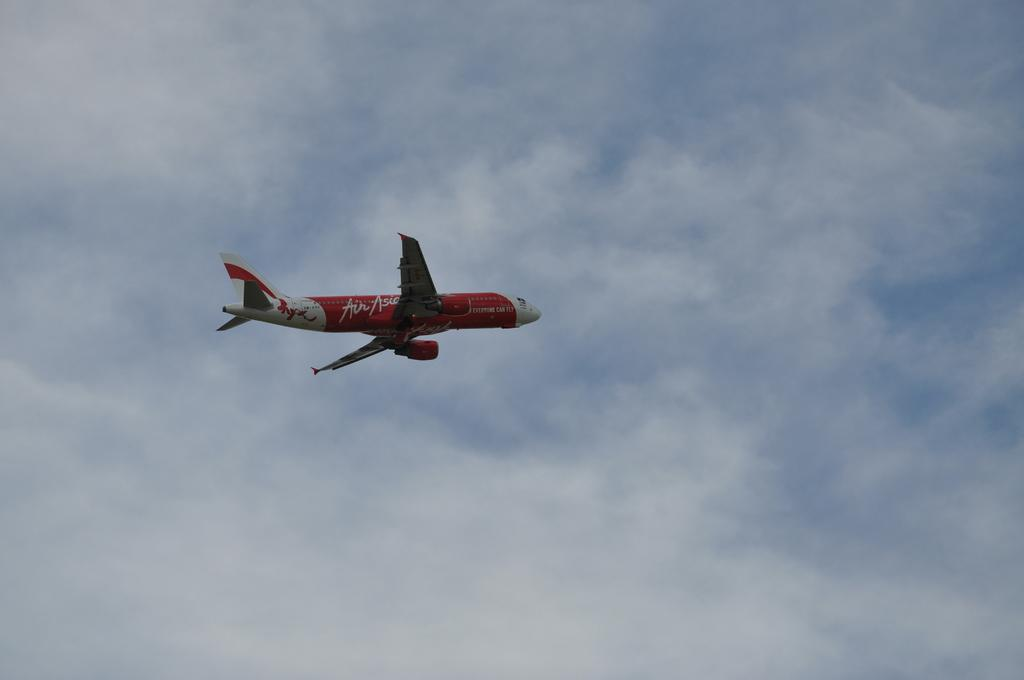What is the main subject of the image? The main subject of the image is an airplane. What is the airplane doing in the image? The airplane is flying in the sky. How does the sky look in the image? The sky is cloudy in the image. Can you see any women playing in a band on the airplane in the image? There are no women or band present on the airplane in the image. What phase of the moon is visible in the image? The image does not show the moon; it only shows an airplane flying in a cloudy sky. 